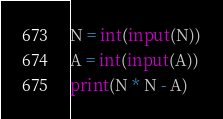<code> <loc_0><loc_0><loc_500><loc_500><_Python_>N = int(input(N))
A = int(input(A))
print(N * N - A)</code> 